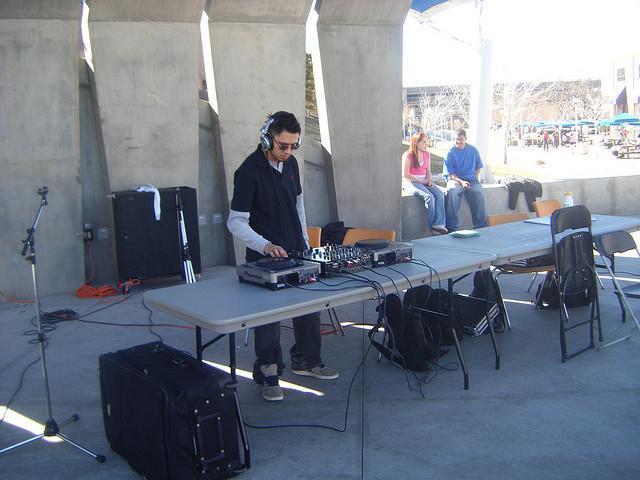How many chairs are around the table?
Give a very brief answer. 6. How many chairs are in the photo?
Give a very brief answer. 2. How many people are in the picture?
Give a very brief answer. 3. 